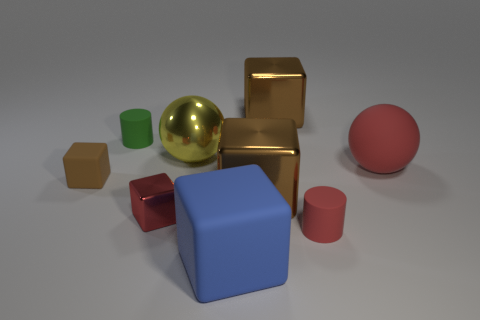Subtract all gray spheres. How many brown cubes are left? 3 Subtract all red blocks. How many blocks are left? 4 Subtract all large rubber blocks. How many blocks are left? 4 Subtract all gray cubes. Subtract all brown spheres. How many cubes are left? 5 Add 1 large yellow cylinders. How many objects exist? 10 Subtract all cubes. How many objects are left? 4 Add 2 brown metallic objects. How many brown metallic objects are left? 4 Add 3 cylinders. How many cylinders exist? 5 Subtract 1 red cubes. How many objects are left? 8 Subtract all shiny blocks. Subtract all small brown matte blocks. How many objects are left? 5 